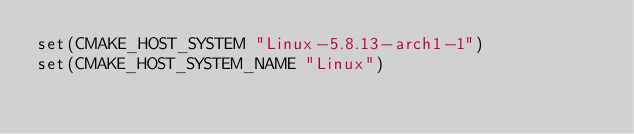<code> <loc_0><loc_0><loc_500><loc_500><_CMake_>set(CMAKE_HOST_SYSTEM "Linux-5.8.13-arch1-1")
set(CMAKE_HOST_SYSTEM_NAME "Linux")</code> 